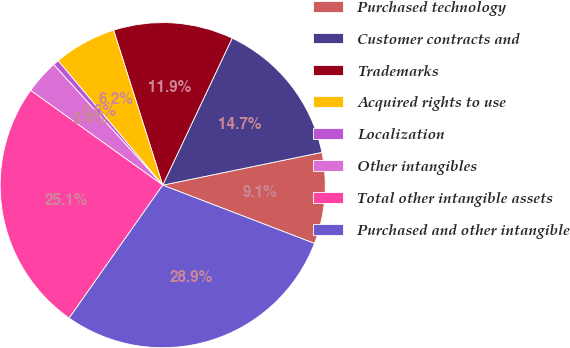Convert chart to OTSL. <chart><loc_0><loc_0><loc_500><loc_500><pie_chart><fcel>Purchased technology<fcel>Customer contracts and<fcel>Trademarks<fcel>Acquired rights to use<fcel>Localization<fcel>Other intangibles<fcel>Total other intangible assets<fcel>Purchased and other intangible<nl><fcel>9.07%<fcel>14.74%<fcel>11.91%<fcel>6.24%<fcel>0.57%<fcel>3.4%<fcel>25.14%<fcel>28.92%<nl></chart> 